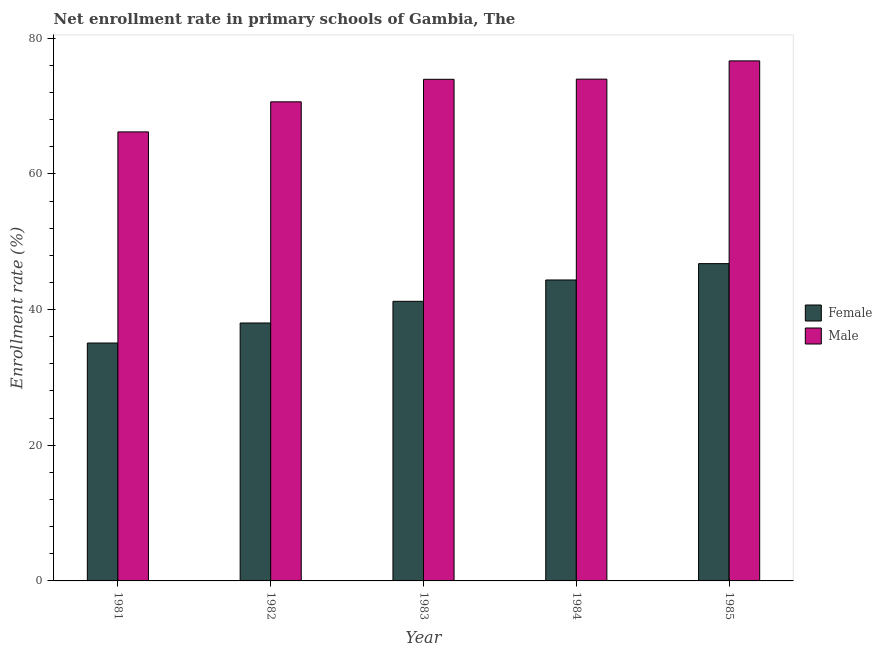How many different coloured bars are there?
Offer a very short reply. 2. How many groups of bars are there?
Ensure brevity in your answer.  5. Are the number of bars on each tick of the X-axis equal?
Your response must be concise. Yes. In how many cases, is the number of bars for a given year not equal to the number of legend labels?
Your answer should be very brief. 0. What is the enrollment rate of female students in 1981?
Your answer should be compact. 35.07. Across all years, what is the maximum enrollment rate of female students?
Offer a very short reply. 46.77. Across all years, what is the minimum enrollment rate of female students?
Keep it short and to the point. 35.07. What is the total enrollment rate of male students in the graph?
Give a very brief answer. 361.38. What is the difference between the enrollment rate of male students in 1981 and that in 1982?
Provide a succinct answer. -4.43. What is the difference between the enrollment rate of female students in 1981 and the enrollment rate of male students in 1982?
Offer a terse response. -2.95. What is the average enrollment rate of female students per year?
Make the answer very short. 41.09. In how many years, is the enrollment rate of male students greater than 24 %?
Provide a short and direct response. 5. What is the ratio of the enrollment rate of male students in 1982 to that in 1985?
Provide a short and direct response. 0.92. Is the enrollment rate of female students in 1981 less than that in 1982?
Provide a short and direct response. Yes. What is the difference between the highest and the second highest enrollment rate of male students?
Provide a short and direct response. 2.69. What is the difference between the highest and the lowest enrollment rate of female students?
Your answer should be very brief. 11.7. In how many years, is the enrollment rate of male students greater than the average enrollment rate of male students taken over all years?
Your answer should be very brief. 3. Is the sum of the enrollment rate of male students in 1981 and 1985 greater than the maximum enrollment rate of female students across all years?
Offer a very short reply. Yes. Are all the bars in the graph horizontal?
Keep it short and to the point. No. What is the difference between two consecutive major ticks on the Y-axis?
Your response must be concise. 20. Does the graph contain any zero values?
Your answer should be compact. No. Where does the legend appear in the graph?
Ensure brevity in your answer.  Center right. How many legend labels are there?
Ensure brevity in your answer.  2. How are the legend labels stacked?
Make the answer very short. Vertical. What is the title of the graph?
Your answer should be very brief. Net enrollment rate in primary schools of Gambia, The. Does "Long-term debt" appear as one of the legend labels in the graph?
Offer a very short reply. No. What is the label or title of the Y-axis?
Provide a succinct answer. Enrollment rate (%). What is the Enrollment rate (%) in Female in 1981?
Offer a very short reply. 35.07. What is the Enrollment rate (%) in Male in 1981?
Ensure brevity in your answer.  66.19. What is the Enrollment rate (%) of Female in 1982?
Keep it short and to the point. 38.02. What is the Enrollment rate (%) of Male in 1982?
Ensure brevity in your answer.  70.62. What is the Enrollment rate (%) in Female in 1983?
Keep it short and to the point. 41.21. What is the Enrollment rate (%) in Male in 1983?
Ensure brevity in your answer.  73.94. What is the Enrollment rate (%) of Female in 1984?
Your answer should be compact. 44.36. What is the Enrollment rate (%) of Male in 1984?
Your answer should be very brief. 73.97. What is the Enrollment rate (%) in Female in 1985?
Provide a short and direct response. 46.77. What is the Enrollment rate (%) of Male in 1985?
Make the answer very short. 76.66. Across all years, what is the maximum Enrollment rate (%) in Female?
Keep it short and to the point. 46.77. Across all years, what is the maximum Enrollment rate (%) in Male?
Offer a very short reply. 76.66. Across all years, what is the minimum Enrollment rate (%) in Female?
Give a very brief answer. 35.07. Across all years, what is the minimum Enrollment rate (%) in Male?
Make the answer very short. 66.19. What is the total Enrollment rate (%) in Female in the graph?
Your answer should be compact. 205.43. What is the total Enrollment rate (%) of Male in the graph?
Offer a very short reply. 361.38. What is the difference between the Enrollment rate (%) in Female in 1981 and that in 1982?
Make the answer very short. -2.95. What is the difference between the Enrollment rate (%) of Male in 1981 and that in 1982?
Your answer should be compact. -4.43. What is the difference between the Enrollment rate (%) in Female in 1981 and that in 1983?
Give a very brief answer. -6.15. What is the difference between the Enrollment rate (%) of Male in 1981 and that in 1983?
Your answer should be compact. -7.75. What is the difference between the Enrollment rate (%) of Female in 1981 and that in 1984?
Make the answer very short. -9.3. What is the difference between the Enrollment rate (%) of Male in 1981 and that in 1984?
Give a very brief answer. -7.78. What is the difference between the Enrollment rate (%) in Female in 1981 and that in 1985?
Your answer should be compact. -11.7. What is the difference between the Enrollment rate (%) of Male in 1981 and that in 1985?
Make the answer very short. -10.47. What is the difference between the Enrollment rate (%) of Female in 1982 and that in 1983?
Provide a short and direct response. -3.19. What is the difference between the Enrollment rate (%) in Male in 1982 and that in 1983?
Make the answer very short. -3.32. What is the difference between the Enrollment rate (%) of Female in 1982 and that in 1984?
Make the answer very short. -6.34. What is the difference between the Enrollment rate (%) in Male in 1982 and that in 1984?
Your response must be concise. -3.34. What is the difference between the Enrollment rate (%) of Female in 1982 and that in 1985?
Your response must be concise. -8.75. What is the difference between the Enrollment rate (%) of Male in 1982 and that in 1985?
Make the answer very short. -6.03. What is the difference between the Enrollment rate (%) of Female in 1983 and that in 1984?
Your response must be concise. -3.15. What is the difference between the Enrollment rate (%) of Male in 1983 and that in 1984?
Ensure brevity in your answer.  -0.03. What is the difference between the Enrollment rate (%) in Female in 1983 and that in 1985?
Give a very brief answer. -5.56. What is the difference between the Enrollment rate (%) of Male in 1983 and that in 1985?
Ensure brevity in your answer.  -2.72. What is the difference between the Enrollment rate (%) in Female in 1984 and that in 1985?
Provide a succinct answer. -2.41. What is the difference between the Enrollment rate (%) of Male in 1984 and that in 1985?
Offer a terse response. -2.69. What is the difference between the Enrollment rate (%) in Female in 1981 and the Enrollment rate (%) in Male in 1982?
Ensure brevity in your answer.  -35.56. What is the difference between the Enrollment rate (%) in Female in 1981 and the Enrollment rate (%) in Male in 1983?
Ensure brevity in your answer.  -38.87. What is the difference between the Enrollment rate (%) of Female in 1981 and the Enrollment rate (%) of Male in 1984?
Your response must be concise. -38.9. What is the difference between the Enrollment rate (%) in Female in 1981 and the Enrollment rate (%) in Male in 1985?
Ensure brevity in your answer.  -41.59. What is the difference between the Enrollment rate (%) in Female in 1982 and the Enrollment rate (%) in Male in 1983?
Your answer should be compact. -35.92. What is the difference between the Enrollment rate (%) of Female in 1982 and the Enrollment rate (%) of Male in 1984?
Offer a terse response. -35.95. What is the difference between the Enrollment rate (%) of Female in 1982 and the Enrollment rate (%) of Male in 1985?
Make the answer very short. -38.64. What is the difference between the Enrollment rate (%) in Female in 1983 and the Enrollment rate (%) in Male in 1984?
Ensure brevity in your answer.  -32.75. What is the difference between the Enrollment rate (%) of Female in 1983 and the Enrollment rate (%) of Male in 1985?
Ensure brevity in your answer.  -35.44. What is the difference between the Enrollment rate (%) in Female in 1984 and the Enrollment rate (%) in Male in 1985?
Ensure brevity in your answer.  -32.3. What is the average Enrollment rate (%) in Female per year?
Your answer should be very brief. 41.09. What is the average Enrollment rate (%) in Male per year?
Your answer should be compact. 72.28. In the year 1981, what is the difference between the Enrollment rate (%) in Female and Enrollment rate (%) in Male?
Offer a terse response. -31.12. In the year 1982, what is the difference between the Enrollment rate (%) of Female and Enrollment rate (%) of Male?
Keep it short and to the point. -32.6. In the year 1983, what is the difference between the Enrollment rate (%) in Female and Enrollment rate (%) in Male?
Your answer should be compact. -32.73. In the year 1984, what is the difference between the Enrollment rate (%) of Female and Enrollment rate (%) of Male?
Give a very brief answer. -29.61. In the year 1985, what is the difference between the Enrollment rate (%) of Female and Enrollment rate (%) of Male?
Offer a terse response. -29.89. What is the ratio of the Enrollment rate (%) in Female in 1981 to that in 1982?
Offer a very short reply. 0.92. What is the ratio of the Enrollment rate (%) of Male in 1981 to that in 1982?
Make the answer very short. 0.94. What is the ratio of the Enrollment rate (%) of Female in 1981 to that in 1983?
Make the answer very short. 0.85. What is the ratio of the Enrollment rate (%) in Male in 1981 to that in 1983?
Your answer should be very brief. 0.9. What is the ratio of the Enrollment rate (%) in Female in 1981 to that in 1984?
Make the answer very short. 0.79. What is the ratio of the Enrollment rate (%) in Male in 1981 to that in 1984?
Provide a succinct answer. 0.89. What is the ratio of the Enrollment rate (%) of Female in 1981 to that in 1985?
Provide a short and direct response. 0.75. What is the ratio of the Enrollment rate (%) of Male in 1981 to that in 1985?
Your answer should be very brief. 0.86. What is the ratio of the Enrollment rate (%) in Female in 1982 to that in 1983?
Your response must be concise. 0.92. What is the ratio of the Enrollment rate (%) of Male in 1982 to that in 1983?
Make the answer very short. 0.96. What is the ratio of the Enrollment rate (%) in Female in 1982 to that in 1984?
Your answer should be very brief. 0.86. What is the ratio of the Enrollment rate (%) in Male in 1982 to that in 1984?
Offer a terse response. 0.95. What is the ratio of the Enrollment rate (%) of Female in 1982 to that in 1985?
Give a very brief answer. 0.81. What is the ratio of the Enrollment rate (%) in Male in 1982 to that in 1985?
Provide a succinct answer. 0.92. What is the ratio of the Enrollment rate (%) in Female in 1983 to that in 1984?
Provide a short and direct response. 0.93. What is the ratio of the Enrollment rate (%) of Male in 1983 to that in 1984?
Your answer should be compact. 1. What is the ratio of the Enrollment rate (%) in Female in 1983 to that in 1985?
Ensure brevity in your answer.  0.88. What is the ratio of the Enrollment rate (%) in Male in 1983 to that in 1985?
Your response must be concise. 0.96. What is the ratio of the Enrollment rate (%) of Female in 1984 to that in 1985?
Offer a terse response. 0.95. What is the ratio of the Enrollment rate (%) in Male in 1984 to that in 1985?
Ensure brevity in your answer.  0.96. What is the difference between the highest and the second highest Enrollment rate (%) of Female?
Ensure brevity in your answer.  2.41. What is the difference between the highest and the second highest Enrollment rate (%) in Male?
Make the answer very short. 2.69. What is the difference between the highest and the lowest Enrollment rate (%) of Female?
Offer a terse response. 11.7. What is the difference between the highest and the lowest Enrollment rate (%) of Male?
Keep it short and to the point. 10.47. 